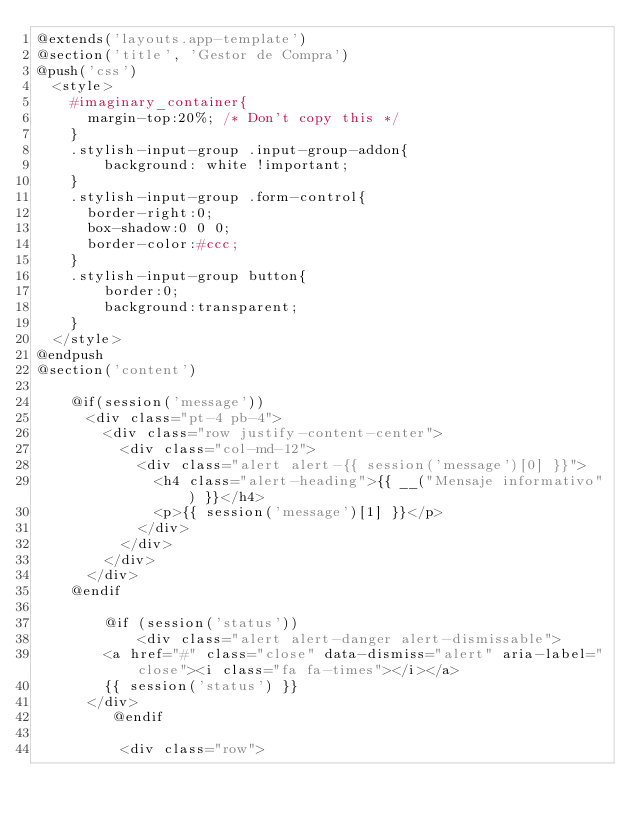Convert code to text. <code><loc_0><loc_0><loc_500><loc_500><_PHP_>@extends('layouts.app-template')
@section('title', 'Gestor de Compra')
@push('css')
	<style>
		#imaginary_container{
	    margin-top:20%; /* Don't copy this */
		}
		.stylish-input-group .input-group-addon{
		    background: white !important;
		}
		.stylish-input-group .form-control{
			border-right:0;
			box-shadow:0 0 0;
			border-color:#ccc;
		}
		.stylish-input-group button{
		    border:0;
		    background:transparent;
		}
	</style>
@endpush
@section('content')

		@if(session('message'))
			<div class="pt-4 pb-4">
				<div class="row justify-content-center">
					<div class="col-md-12">
						<div class="alert alert-{{ session('message')[0] }}">
							<h4 class="alert-heading">{{ __("Mensaje informativo") }}</h4>
							<p>{{ session('message')[1] }}</p>
						</div>
					</div>
				</div>
			</div>
		@endif

        @if (session('status'))
            <div class="alert alert-danger alert-dismissable">
			  <a href="#" class="close" data-dismiss="alert" aria-label="close"><i class="fa fa-times"></i></a>
			  {{ session('status') }}
			</div>
         @endif

          <div class="row"></code> 